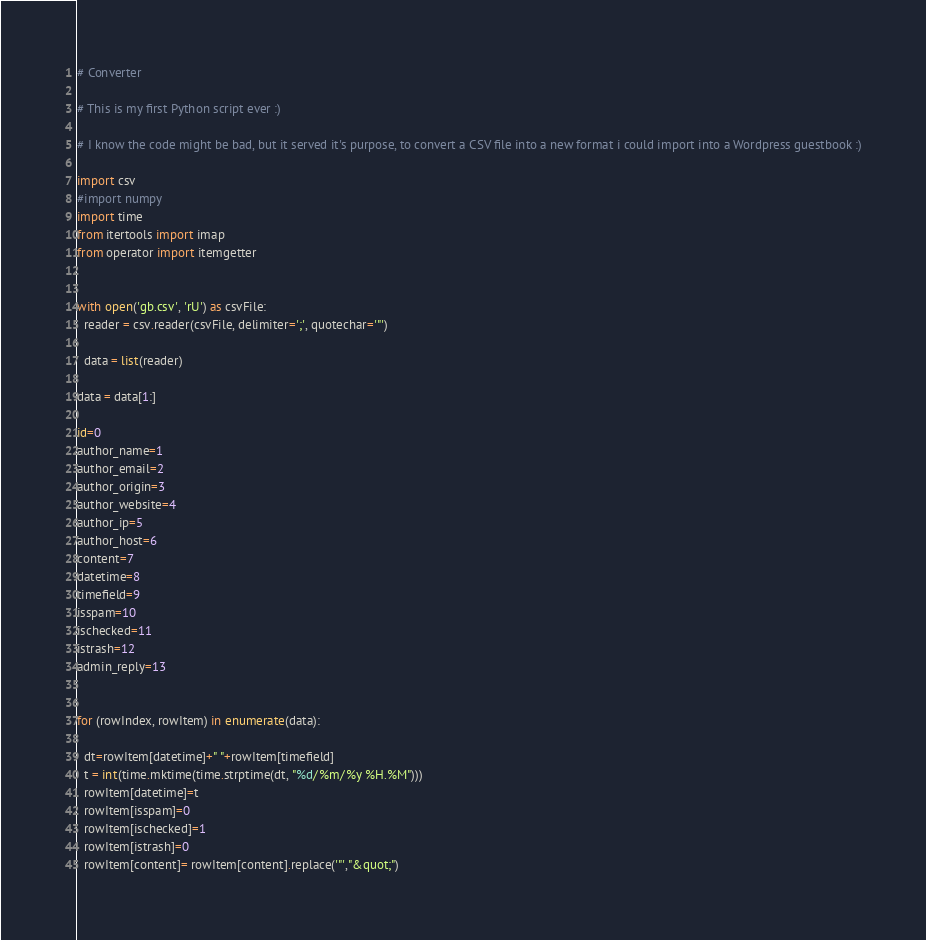Convert code to text. <code><loc_0><loc_0><loc_500><loc_500><_Python_># Converter

# This is my first Python script ever :)

# I know the code might be bad, but it served it's purpose, to convert a CSV file into a new format i could import into a Wordpress guestbook :)

import csv
#import numpy 
import time
from itertools import imap
from operator import itemgetter


with open('gb.csv', 'rU') as csvFile:
  reader = csv.reader(csvFile, delimiter=';', quotechar='"')
  
  data = list(reader)

data = data[1:]

id=0
author_name=1
author_email=2
author_origin=3
author_website=4
author_ip=5
author_host=6
content=7
datetime=8
timefield=9
isspam=10
ischecked=11
istrash=12
admin_reply=13


for (rowIndex, rowItem) in enumerate(data):
  
  dt=rowItem[datetime]+" "+rowItem[timefield]
  t = int(time.mktime(time.strptime(dt, "%d/%m/%y %H.%M")))
  rowItem[datetime]=t
  rowItem[isspam]=0
  rowItem[ischecked]=1
  rowItem[istrash]=0
  rowItem[content]= rowItem[content].replace('"',"&quot;")
</code> 